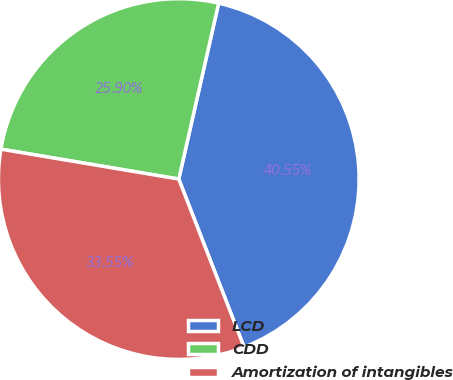<chart> <loc_0><loc_0><loc_500><loc_500><pie_chart><fcel>LCD<fcel>CDD<fcel>Amortization of intangibles<nl><fcel>40.55%<fcel>25.9%<fcel>33.55%<nl></chart> 